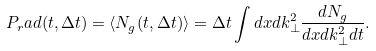Convert formula to latex. <formula><loc_0><loc_0><loc_500><loc_500>P _ { r } a d ( t , \Delta t ) = \langle N _ { g } ( t , \Delta t ) \rangle = \Delta t \int d x d k _ { \perp } ^ { 2 } \frac { d N _ { g } } { d x d k _ { \perp } ^ { 2 } d t } .</formula> 